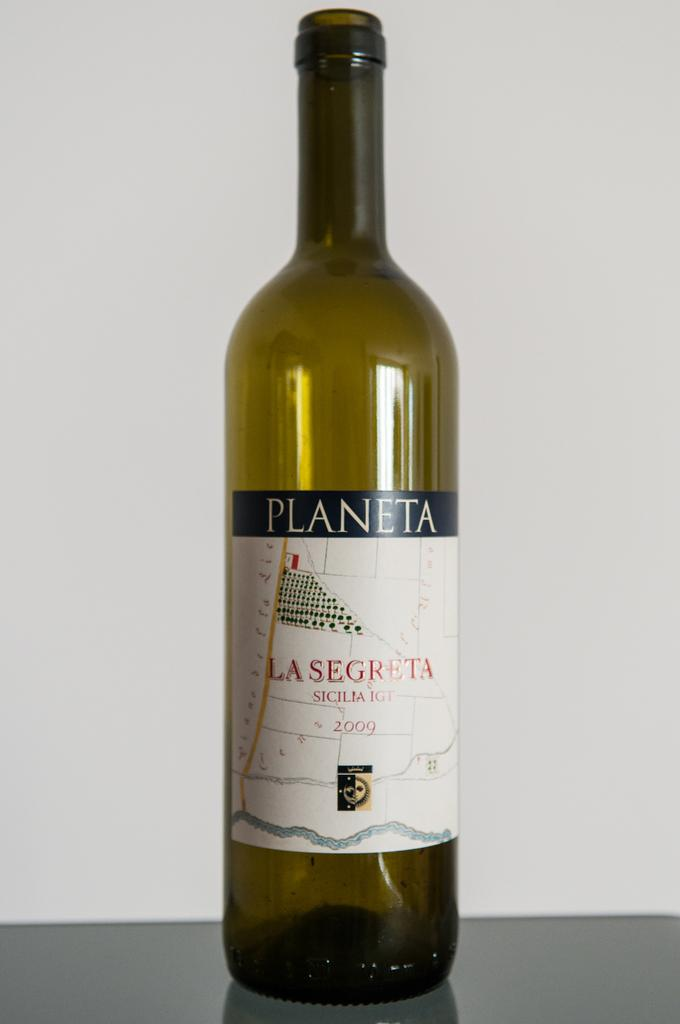Provide a one-sentence caption for the provided image. An empty bottle that once contained a 2009 vintage of Planeta wine. 